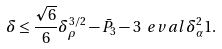<formula> <loc_0><loc_0><loc_500><loc_500>\delta \leq \frac { \sqrt { 6 } } { 6 } \delta _ { \rho } ^ { 3 / 2 } - \bar { P } _ { 3 } - 3 \ e v a l { \delta _ { \alpha } ^ { 2 } } { 1 } .</formula> 